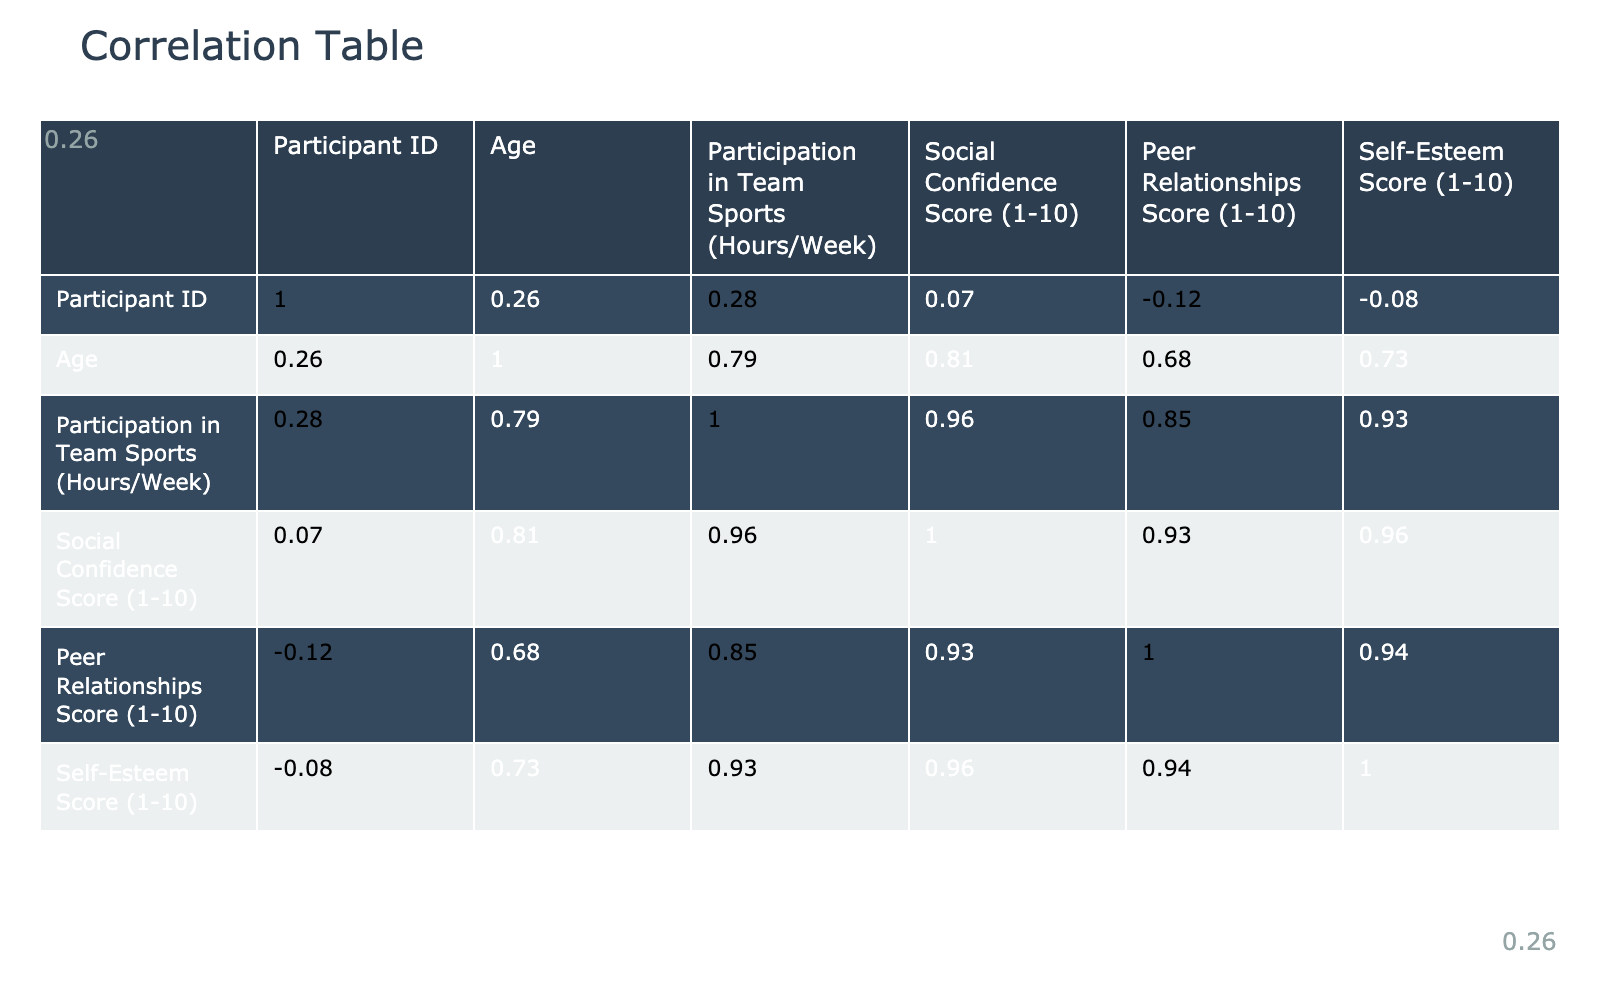What is the correlation between participation in team sports and social confidence? Looking at the correlation table, the value that represents this correlation is 0.77, indicating a strong positive relationship between the two variables.
Answer: 0.77 What is the highest social confidence score in the dataset? Reviewing the social confidence score column, the highest score is 9, which appears for participants 3 and 8.
Answer: 9 Is there a participant who has both high participation in team sports and high self-esteem? Participant 3 has a participation of 7 hours in team sports and a self-esteem score of 8, which qualifies as high in both categories.
Answer: Yes Which participant has the lowest social confidence score? By looking through the social confidence scores, participant 4 has the lowest score of 5.
Answer: 5 What is the average self-esteem score of participants who participate in team sports for more than 5 hours a week? Participants with more than 5 hours of sports participation are 3, 5, and 8. Their self-esteem scores are 8, 7, and 8 respectively. The average is (8 + 7 + 8)/3 = 7.67.
Answer: 7.67 Are the peer relationships score and social confidence score correlated? The correlation table shows a correlation of 0.73 between peer relationships and social confidence, which indicates a strong positive relationship.
Answer: Yes What is the difference in participation hours between the participant with the highest and lowest team sports participation? The participant with the highest participation is participant 8 with 8 hours, and the participant with the lowest is participant 4 with 2 hours. The difference is 8 - 2 = 6 hours.
Answer: 6 hours Which participant has the second-highest participation in team sports? Sorting the participation in team sports, participant 10 has 7 hours, making them the second-highest after participant 8, who has 8 hours.
Answer: Participant 10 What is the correlation between self-esteem and participation in team sports? The correlation table shows a value of 0.60 for self-esteem and participation in team sports, indicating a moderate positive relationship between them.
Answer: 0.60 What can be inferred about the relationship between peer relationships and self-esteem based on the correlation value? The correlation of 0.67 between peer relationships and self-esteem suggests a strong positive relationship, indicating that as peer relationships improve, self-esteem likely increases as well.
Answer: Strong positive relationship 